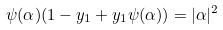<formula> <loc_0><loc_0><loc_500><loc_500>\psi ( \alpha ) ( 1 - y _ { 1 } + y _ { 1 } \psi ( \alpha ) ) = | \alpha | ^ { 2 }</formula> 